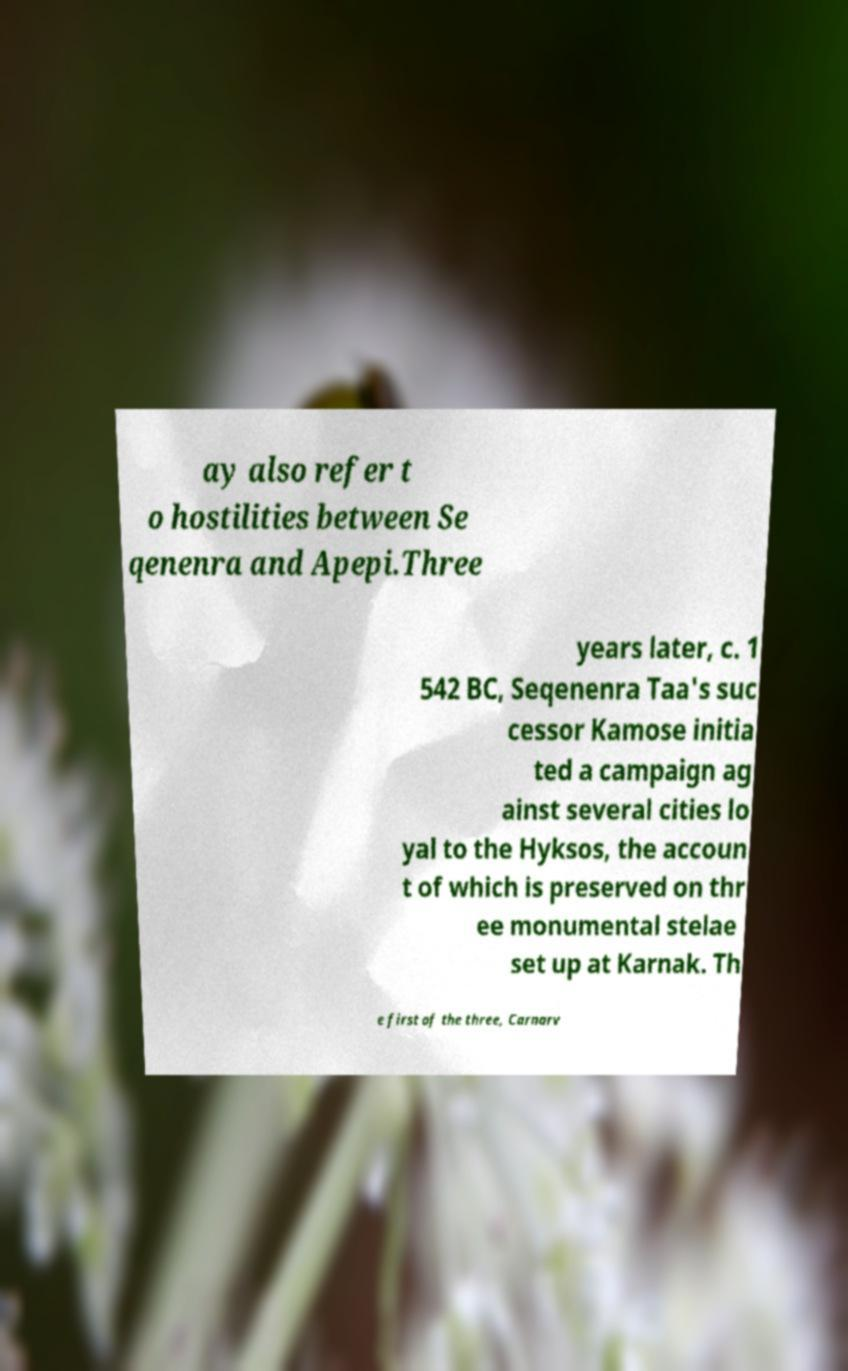Please identify and transcribe the text found in this image. ay also refer t o hostilities between Se qenenra and Apepi.Three years later, c. 1 542 BC, Seqenenra Taa's suc cessor Kamose initia ted a campaign ag ainst several cities lo yal to the Hyksos, the accoun t of which is preserved on thr ee monumental stelae set up at Karnak. Th e first of the three, Carnarv 